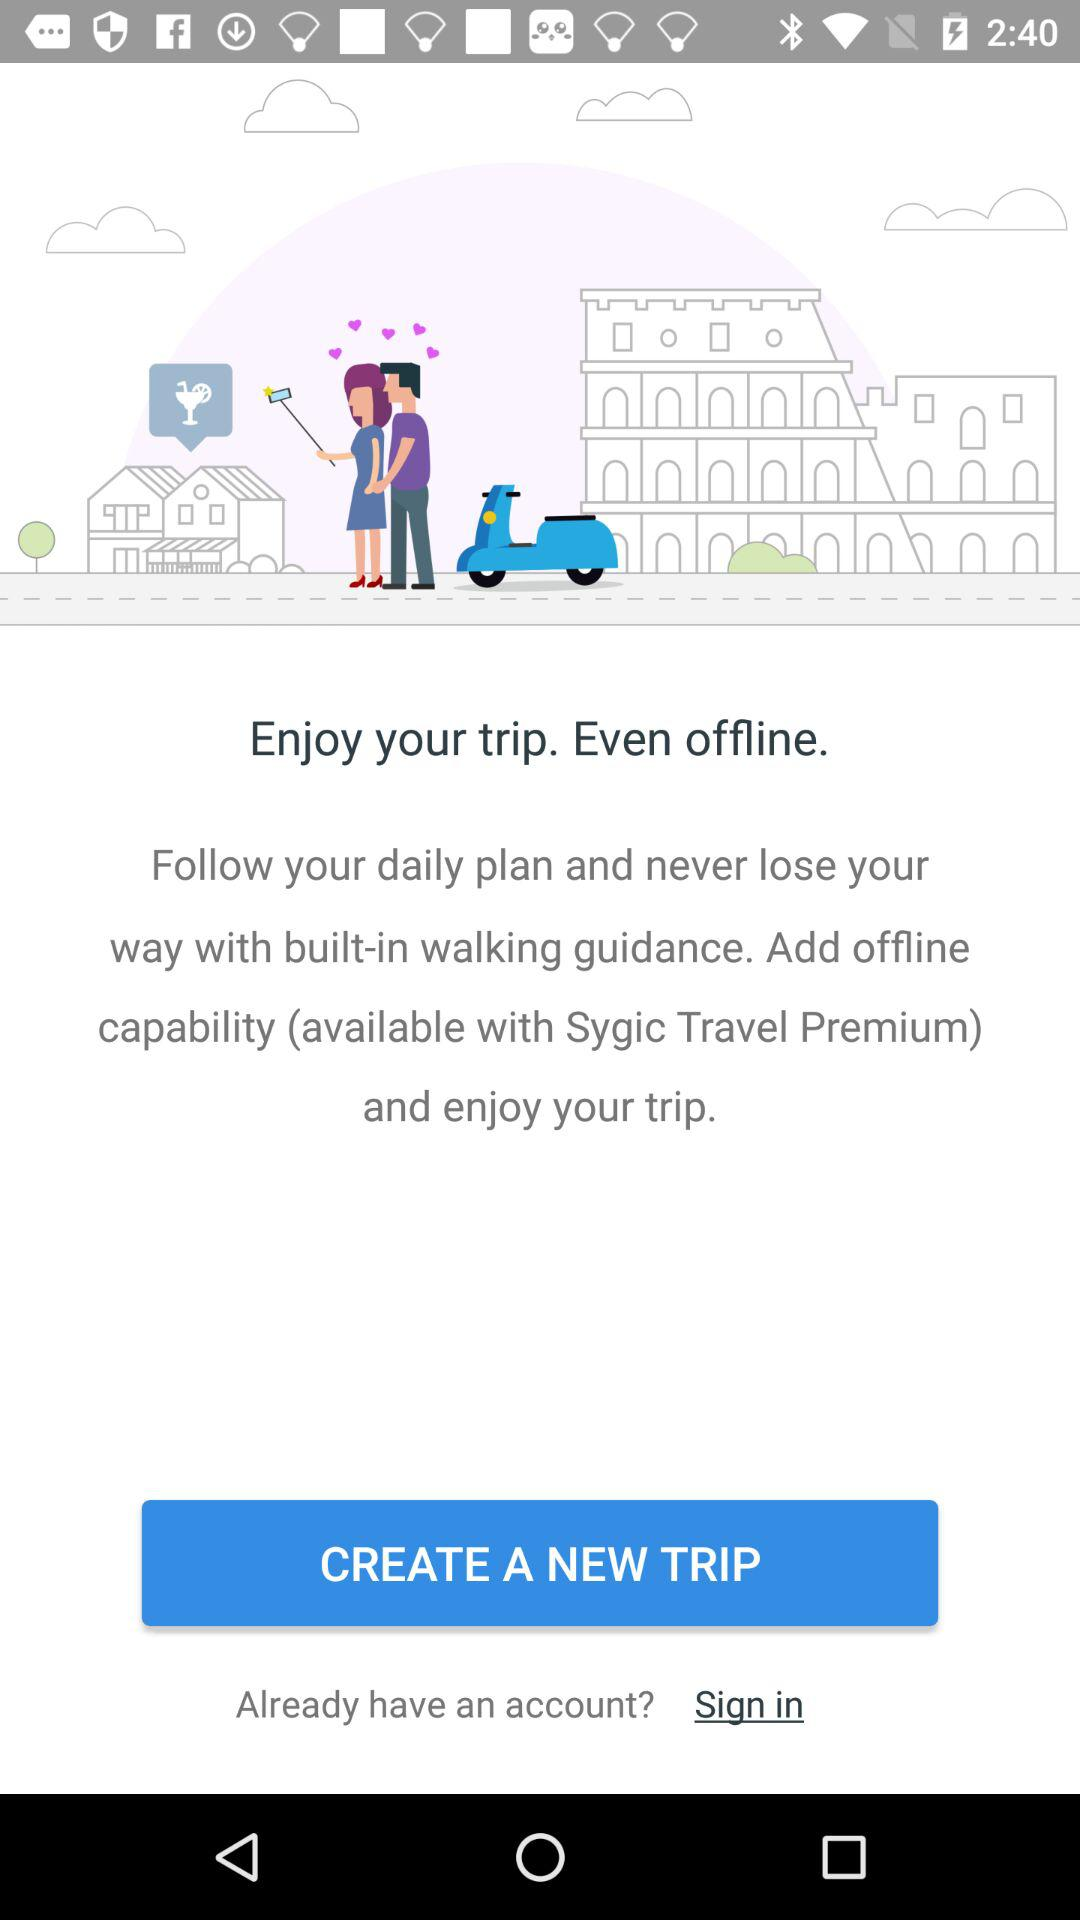When is the new trip scheduled?
When the provided information is insufficient, respond with <no answer>. <no answer> 